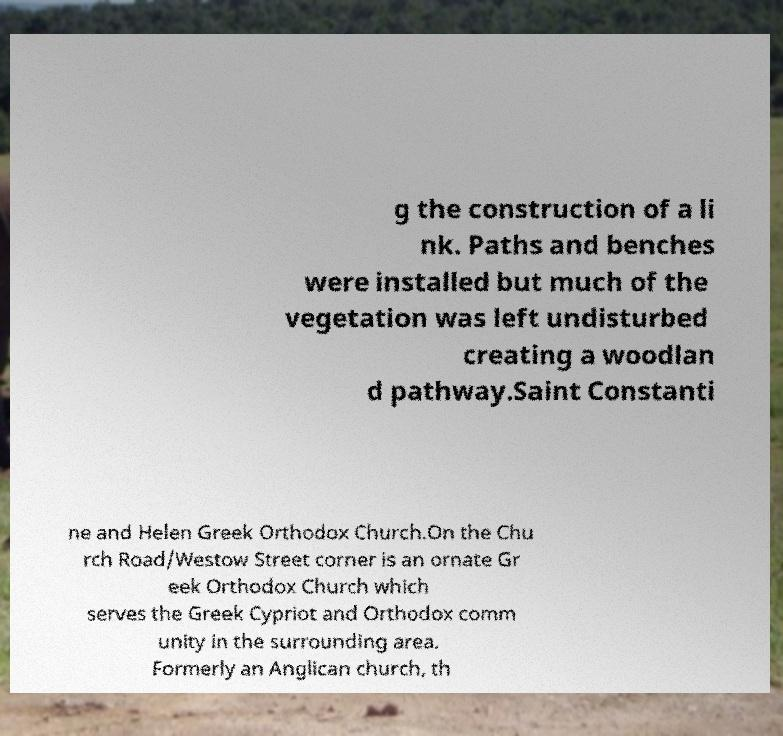What messages or text are displayed in this image? I need them in a readable, typed format. g the construction of a li nk. Paths and benches were installed but much of the vegetation was left undisturbed creating a woodlan d pathway.Saint Constanti ne and Helen Greek Orthodox Church.On the Chu rch Road/Westow Street corner is an ornate Gr eek Orthodox Church which serves the Greek Cypriot and Orthodox comm unity in the surrounding area. Formerly an Anglican church, th 